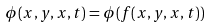<formula> <loc_0><loc_0><loc_500><loc_500>\phi ( x , y , x , t ) = \phi ( f ( x , y , x , t ) )</formula> 